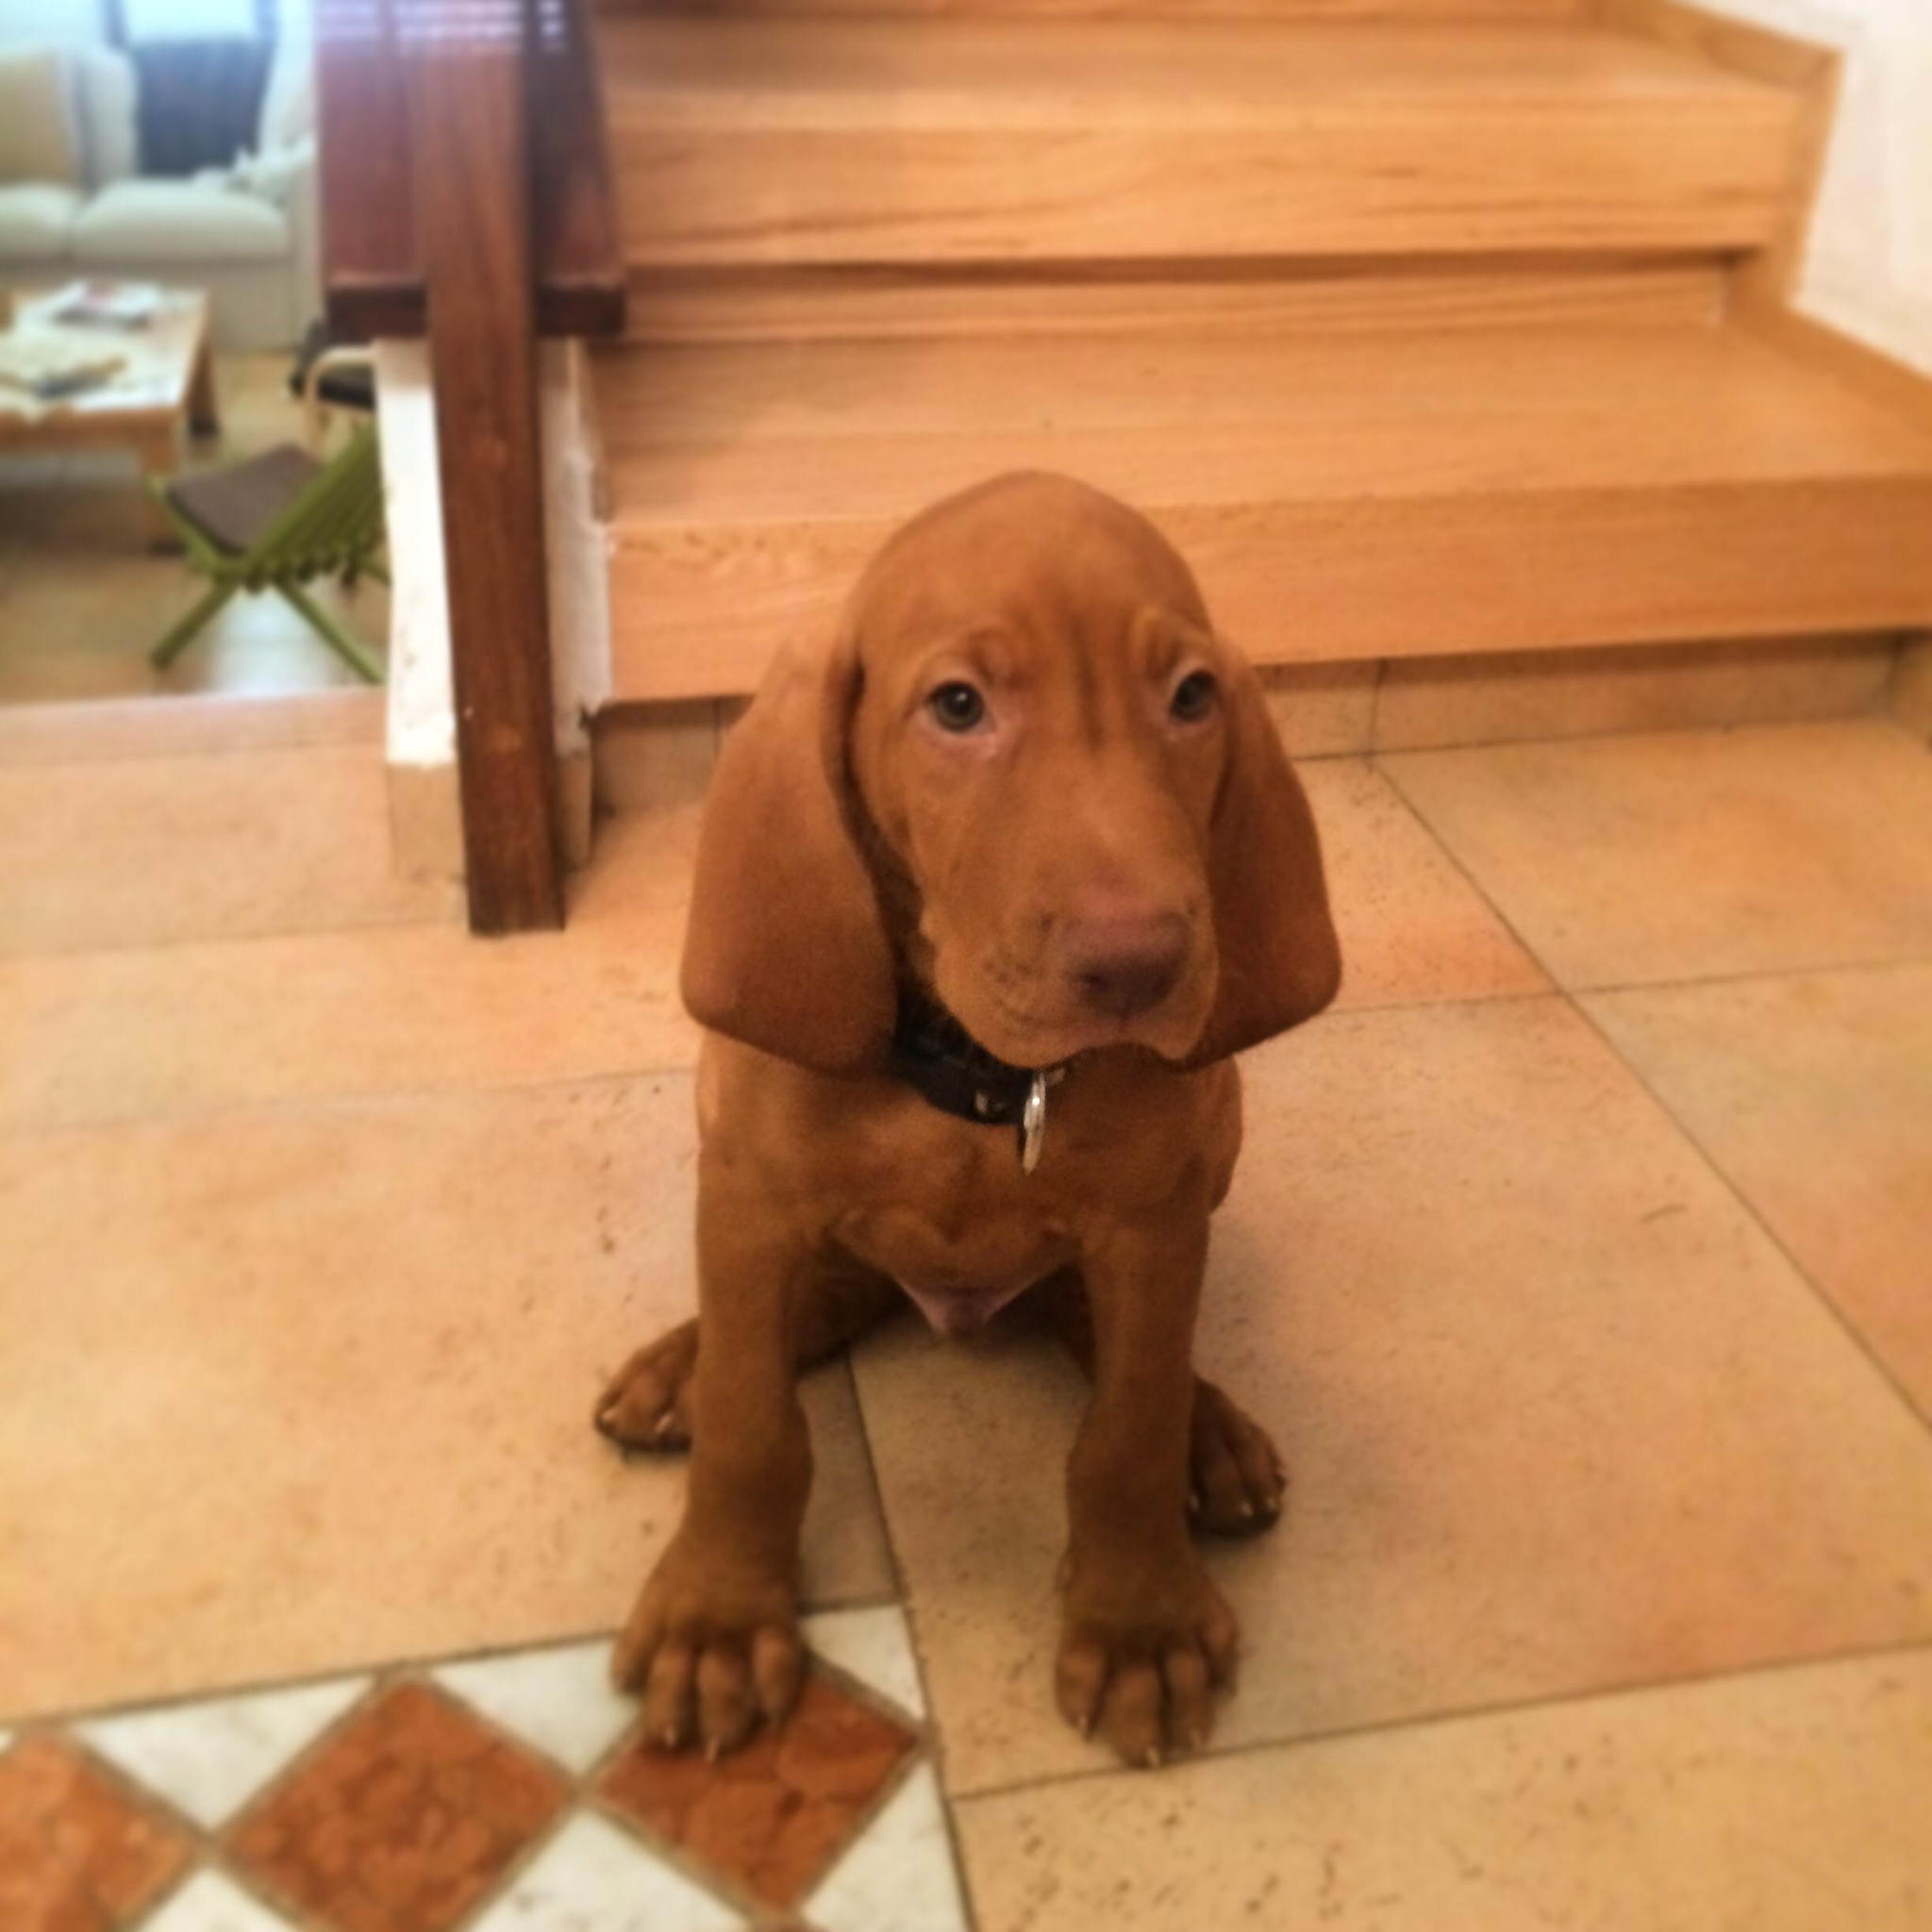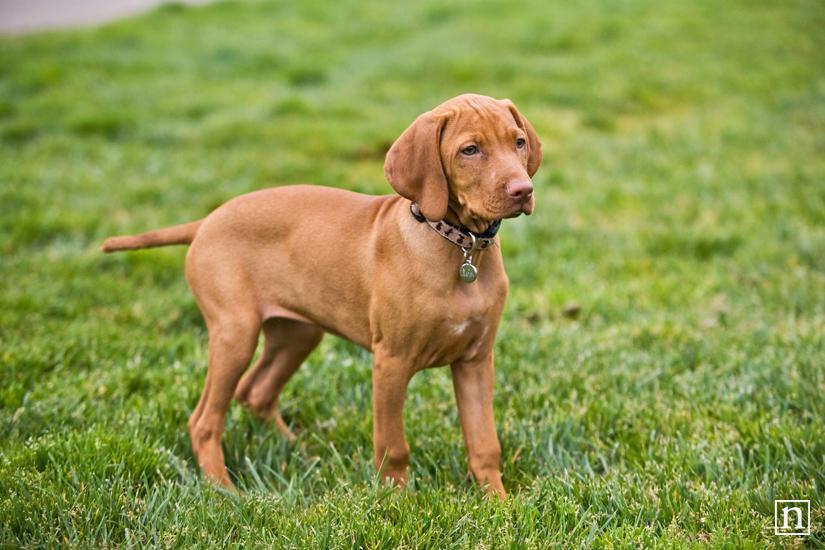The first image is the image on the left, the second image is the image on the right. For the images displayed, is the sentence "At least two dogs are outside." factually correct? Answer yes or no. No. The first image is the image on the left, the second image is the image on the right. Given the left and right images, does the statement "One image shows a rightward-turned dog standing in profile with his tail out straight, and the other image features one puppy in a non-standing pose." hold true? Answer yes or no. Yes. 